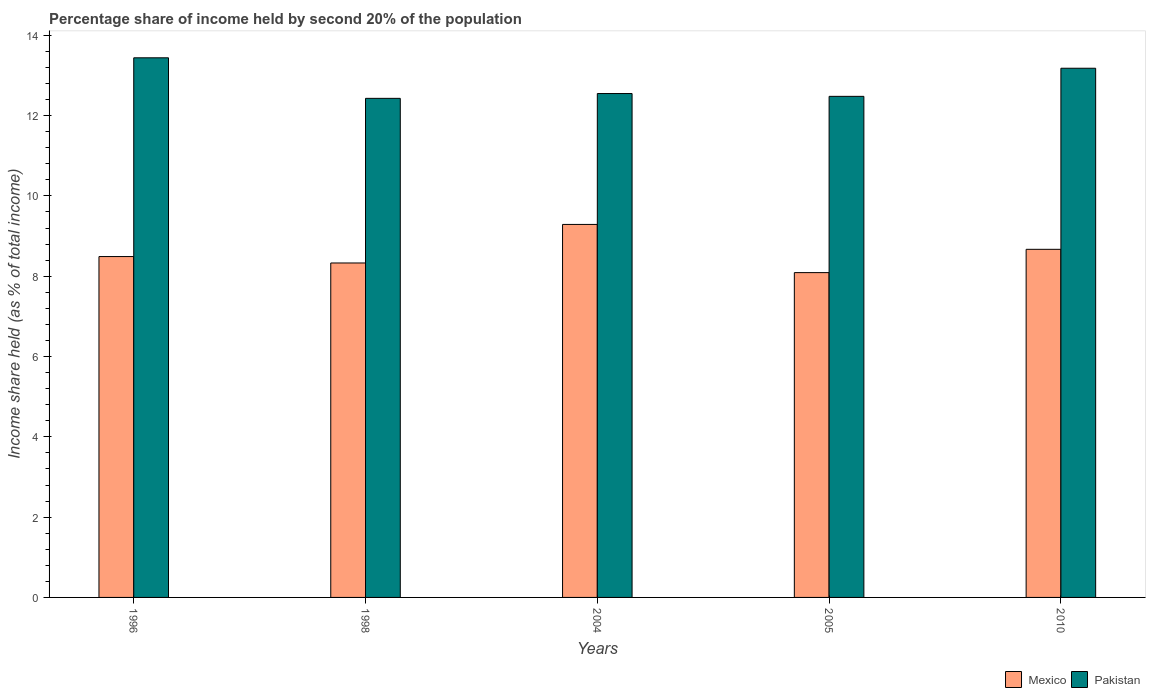How many different coloured bars are there?
Provide a succinct answer. 2. Are the number of bars per tick equal to the number of legend labels?
Offer a terse response. Yes. How many bars are there on the 4th tick from the right?
Ensure brevity in your answer.  2. What is the share of income held by second 20% of the population in Pakistan in 1998?
Offer a terse response. 12.43. Across all years, what is the maximum share of income held by second 20% of the population in Pakistan?
Your response must be concise. 13.44. Across all years, what is the minimum share of income held by second 20% of the population in Pakistan?
Keep it short and to the point. 12.43. In which year was the share of income held by second 20% of the population in Mexico maximum?
Provide a succinct answer. 2004. In which year was the share of income held by second 20% of the population in Mexico minimum?
Your answer should be very brief. 2005. What is the total share of income held by second 20% of the population in Pakistan in the graph?
Your answer should be very brief. 64.08. What is the difference between the share of income held by second 20% of the population in Pakistan in 1996 and that in 2004?
Make the answer very short. 0.89. What is the difference between the share of income held by second 20% of the population in Mexico in 2010 and the share of income held by second 20% of the population in Pakistan in 1996?
Ensure brevity in your answer.  -4.77. What is the average share of income held by second 20% of the population in Mexico per year?
Your response must be concise. 8.57. In the year 2004, what is the difference between the share of income held by second 20% of the population in Pakistan and share of income held by second 20% of the population in Mexico?
Keep it short and to the point. 3.26. In how many years, is the share of income held by second 20% of the population in Mexico greater than 8.8 %?
Make the answer very short. 1. What is the ratio of the share of income held by second 20% of the population in Pakistan in 1996 to that in 2005?
Provide a short and direct response. 1.08. Is the share of income held by second 20% of the population in Mexico in 1998 less than that in 2010?
Your response must be concise. Yes. What is the difference between the highest and the second highest share of income held by second 20% of the population in Pakistan?
Provide a short and direct response. 0.26. What is the difference between the highest and the lowest share of income held by second 20% of the population in Mexico?
Provide a succinct answer. 1.2. In how many years, is the share of income held by second 20% of the population in Pakistan greater than the average share of income held by second 20% of the population in Pakistan taken over all years?
Your response must be concise. 2. Is the sum of the share of income held by second 20% of the population in Pakistan in 2004 and 2010 greater than the maximum share of income held by second 20% of the population in Mexico across all years?
Your answer should be very brief. Yes. What does the 2nd bar from the left in 2004 represents?
Keep it short and to the point. Pakistan. How many bars are there?
Your answer should be very brief. 10. Are all the bars in the graph horizontal?
Keep it short and to the point. No. How many years are there in the graph?
Provide a short and direct response. 5. What is the difference between two consecutive major ticks on the Y-axis?
Provide a short and direct response. 2. Does the graph contain grids?
Your answer should be very brief. No. What is the title of the graph?
Your answer should be very brief. Percentage share of income held by second 20% of the population. What is the label or title of the X-axis?
Offer a very short reply. Years. What is the label or title of the Y-axis?
Ensure brevity in your answer.  Income share held (as % of total income). What is the Income share held (as % of total income) in Mexico in 1996?
Keep it short and to the point. 8.49. What is the Income share held (as % of total income) in Pakistan in 1996?
Your answer should be compact. 13.44. What is the Income share held (as % of total income) in Mexico in 1998?
Provide a short and direct response. 8.33. What is the Income share held (as % of total income) of Pakistan in 1998?
Your answer should be very brief. 12.43. What is the Income share held (as % of total income) of Mexico in 2004?
Provide a succinct answer. 9.29. What is the Income share held (as % of total income) of Pakistan in 2004?
Ensure brevity in your answer.  12.55. What is the Income share held (as % of total income) of Mexico in 2005?
Keep it short and to the point. 8.09. What is the Income share held (as % of total income) in Pakistan in 2005?
Keep it short and to the point. 12.48. What is the Income share held (as % of total income) in Mexico in 2010?
Offer a terse response. 8.67. What is the Income share held (as % of total income) of Pakistan in 2010?
Keep it short and to the point. 13.18. Across all years, what is the maximum Income share held (as % of total income) of Mexico?
Your answer should be very brief. 9.29. Across all years, what is the maximum Income share held (as % of total income) in Pakistan?
Keep it short and to the point. 13.44. Across all years, what is the minimum Income share held (as % of total income) in Mexico?
Offer a very short reply. 8.09. Across all years, what is the minimum Income share held (as % of total income) in Pakistan?
Offer a very short reply. 12.43. What is the total Income share held (as % of total income) of Mexico in the graph?
Your answer should be compact. 42.87. What is the total Income share held (as % of total income) of Pakistan in the graph?
Keep it short and to the point. 64.08. What is the difference between the Income share held (as % of total income) in Mexico in 1996 and that in 1998?
Your response must be concise. 0.16. What is the difference between the Income share held (as % of total income) in Mexico in 1996 and that in 2004?
Provide a succinct answer. -0.8. What is the difference between the Income share held (as % of total income) of Pakistan in 1996 and that in 2004?
Your answer should be compact. 0.89. What is the difference between the Income share held (as % of total income) in Mexico in 1996 and that in 2005?
Keep it short and to the point. 0.4. What is the difference between the Income share held (as % of total income) of Pakistan in 1996 and that in 2005?
Make the answer very short. 0.96. What is the difference between the Income share held (as % of total income) of Mexico in 1996 and that in 2010?
Keep it short and to the point. -0.18. What is the difference between the Income share held (as % of total income) of Pakistan in 1996 and that in 2010?
Your answer should be compact. 0.26. What is the difference between the Income share held (as % of total income) of Mexico in 1998 and that in 2004?
Your response must be concise. -0.96. What is the difference between the Income share held (as % of total income) of Pakistan in 1998 and that in 2004?
Make the answer very short. -0.12. What is the difference between the Income share held (as % of total income) of Mexico in 1998 and that in 2005?
Provide a short and direct response. 0.24. What is the difference between the Income share held (as % of total income) in Mexico in 1998 and that in 2010?
Your answer should be compact. -0.34. What is the difference between the Income share held (as % of total income) of Pakistan in 1998 and that in 2010?
Keep it short and to the point. -0.75. What is the difference between the Income share held (as % of total income) in Pakistan in 2004 and that in 2005?
Offer a very short reply. 0.07. What is the difference between the Income share held (as % of total income) in Mexico in 2004 and that in 2010?
Your answer should be compact. 0.62. What is the difference between the Income share held (as % of total income) of Pakistan in 2004 and that in 2010?
Ensure brevity in your answer.  -0.63. What is the difference between the Income share held (as % of total income) in Mexico in 2005 and that in 2010?
Keep it short and to the point. -0.58. What is the difference between the Income share held (as % of total income) in Pakistan in 2005 and that in 2010?
Your answer should be compact. -0.7. What is the difference between the Income share held (as % of total income) of Mexico in 1996 and the Income share held (as % of total income) of Pakistan in 1998?
Make the answer very short. -3.94. What is the difference between the Income share held (as % of total income) of Mexico in 1996 and the Income share held (as % of total income) of Pakistan in 2004?
Your answer should be very brief. -4.06. What is the difference between the Income share held (as % of total income) in Mexico in 1996 and the Income share held (as % of total income) in Pakistan in 2005?
Provide a succinct answer. -3.99. What is the difference between the Income share held (as % of total income) of Mexico in 1996 and the Income share held (as % of total income) of Pakistan in 2010?
Your answer should be very brief. -4.69. What is the difference between the Income share held (as % of total income) in Mexico in 1998 and the Income share held (as % of total income) in Pakistan in 2004?
Keep it short and to the point. -4.22. What is the difference between the Income share held (as % of total income) in Mexico in 1998 and the Income share held (as % of total income) in Pakistan in 2005?
Your answer should be very brief. -4.15. What is the difference between the Income share held (as % of total income) of Mexico in 1998 and the Income share held (as % of total income) of Pakistan in 2010?
Make the answer very short. -4.85. What is the difference between the Income share held (as % of total income) in Mexico in 2004 and the Income share held (as % of total income) in Pakistan in 2005?
Provide a succinct answer. -3.19. What is the difference between the Income share held (as % of total income) in Mexico in 2004 and the Income share held (as % of total income) in Pakistan in 2010?
Give a very brief answer. -3.89. What is the difference between the Income share held (as % of total income) in Mexico in 2005 and the Income share held (as % of total income) in Pakistan in 2010?
Your response must be concise. -5.09. What is the average Income share held (as % of total income) in Mexico per year?
Your answer should be very brief. 8.57. What is the average Income share held (as % of total income) of Pakistan per year?
Your answer should be very brief. 12.82. In the year 1996, what is the difference between the Income share held (as % of total income) in Mexico and Income share held (as % of total income) in Pakistan?
Make the answer very short. -4.95. In the year 2004, what is the difference between the Income share held (as % of total income) in Mexico and Income share held (as % of total income) in Pakistan?
Provide a short and direct response. -3.26. In the year 2005, what is the difference between the Income share held (as % of total income) in Mexico and Income share held (as % of total income) in Pakistan?
Your response must be concise. -4.39. In the year 2010, what is the difference between the Income share held (as % of total income) in Mexico and Income share held (as % of total income) in Pakistan?
Offer a terse response. -4.51. What is the ratio of the Income share held (as % of total income) of Mexico in 1996 to that in 1998?
Provide a short and direct response. 1.02. What is the ratio of the Income share held (as % of total income) in Pakistan in 1996 to that in 1998?
Ensure brevity in your answer.  1.08. What is the ratio of the Income share held (as % of total income) of Mexico in 1996 to that in 2004?
Make the answer very short. 0.91. What is the ratio of the Income share held (as % of total income) of Pakistan in 1996 to that in 2004?
Your answer should be very brief. 1.07. What is the ratio of the Income share held (as % of total income) of Mexico in 1996 to that in 2005?
Make the answer very short. 1.05. What is the ratio of the Income share held (as % of total income) in Pakistan in 1996 to that in 2005?
Offer a very short reply. 1.08. What is the ratio of the Income share held (as % of total income) in Mexico in 1996 to that in 2010?
Your answer should be very brief. 0.98. What is the ratio of the Income share held (as % of total income) of Pakistan in 1996 to that in 2010?
Give a very brief answer. 1.02. What is the ratio of the Income share held (as % of total income) in Mexico in 1998 to that in 2004?
Give a very brief answer. 0.9. What is the ratio of the Income share held (as % of total income) in Pakistan in 1998 to that in 2004?
Provide a succinct answer. 0.99. What is the ratio of the Income share held (as % of total income) in Mexico in 1998 to that in 2005?
Give a very brief answer. 1.03. What is the ratio of the Income share held (as % of total income) of Pakistan in 1998 to that in 2005?
Offer a terse response. 1. What is the ratio of the Income share held (as % of total income) in Mexico in 1998 to that in 2010?
Keep it short and to the point. 0.96. What is the ratio of the Income share held (as % of total income) of Pakistan in 1998 to that in 2010?
Ensure brevity in your answer.  0.94. What is the ratio of the Income share held (as % of total income) in Mexico in 2004 to that in 2005?
Your response must be concise. 1.15. What is the ratio of the Income share held (as % of total income) in Pakistan in 2004 to that in 2005?
Your answer should be compact. 1.01. What is the ratio of the Income share held (as % of total income) in Mexico in 2004 to that in 2010?
Make the answer very short. 1.07. What is the ratio of the Income share held (as % of total income) in Pakistan in 2004 to that in 2010?
Your answer should be very brief. 0.95. What is the ratio of the Income share held (as % of total income) of Mexico in 2005 to that in 2010?
Keep it short and to the point. 0.93. What is the ratio of the Income share held (as % of total income) of Pakistan in 2005 to that in 2010?
Offer a very short reply. 0.95. What is the difference between the highest and the second highest Income share held (as % of total income) of Mexico?
Provide a short and direct response. 0.62. What is the difference between the highest and the second highest Income share held (as % of total income) in Pakistan?
Keep it short and to the point. 0.26. What is the difference between the highest and the lowest Income share held (as % of total income) of Pakistan?
Offer a very short reply. 1.01. 